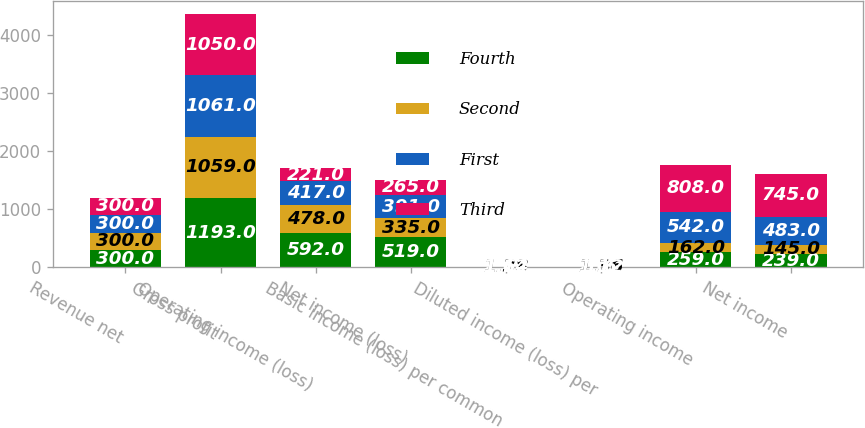Convert chart to OTSL. <chart><loc_0><loc_0><loc_500><loc_500><stacked_bar_chart><ecel><fcel>Revenue net<fcel>Gross profit<fcel>Operating income (loss)<fcel>Net income (loss)<fcel>Basic income (loss) per common<fcel>Diluted income (loss) per<fcel>Operating income<fcel>Net income<nl><fcel>Fourth<fcel>300<fcel>1193<fcel>592<fcel>519<fcel>2.11<fcel>2.06<fcel>259<fcel>239<nl><fcel>Second<fcel>300<fcel>1059<fcel>478<fcel>335<fcel>1.38<fcel>1.36<fcel>162<fcel>145<nl><fcel>First<fcel>300<fcel>1061<fcel>417<fcel>391<fcel>1.64<fcel>1.6<fcel>542<fcel>483<nl><fcel>Third<fcel>300<fcel>1050<fcel>221<fcel>265<fcel>1.12<fcel>1.12<fcel>808<fcel>745<nl></chart> 